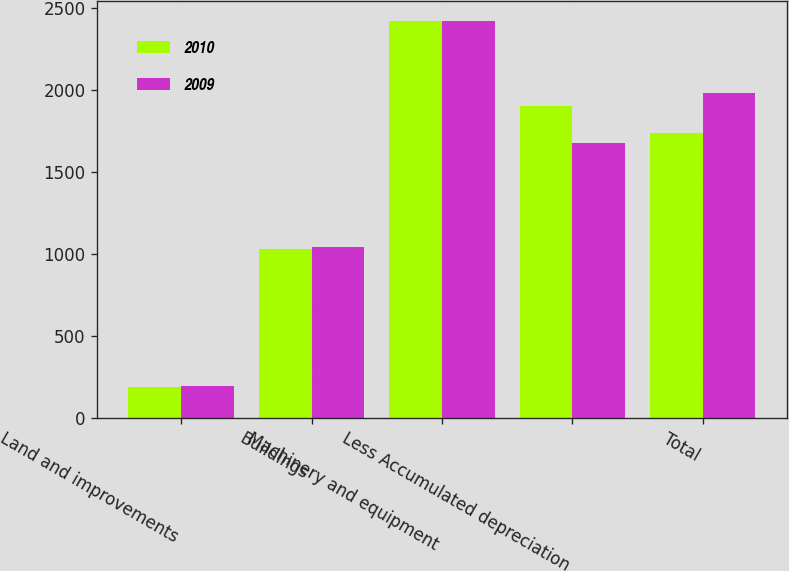<chart> <loc_0><loc_0><loc_500><loc_500><stacked_bar_chart><ecel><fcel>Land and improvements<fcel>Buildings<fcel>Machinery and equipment<fcel>Less Accumulated depreciation<fcel>Total<nl><fcel>2010<fcel>190<fcel>1030<fcel>2419<fcel>1902<fcel>1737<nl><fcel>2009<fcel>195<fcel>1044<fcel>2420<fcel>1678<fcel>1981<nl></chart> 